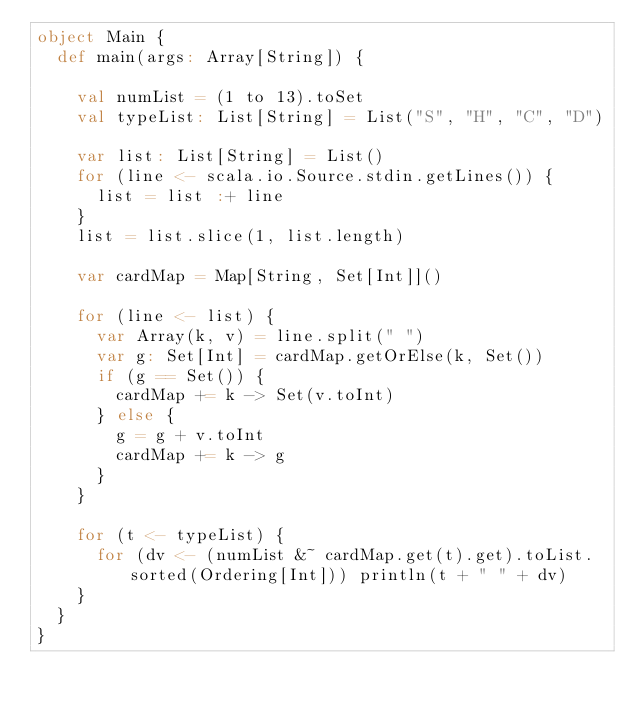<code> <loc_0><loc_0><loc_500><loc_500><_Scala_>object Main {
  def main(args: Array[String]) {

    val numList = (1 to 13).toSet
    val typeList: List[String] = List("S", "H", "C", "D")

    var list: List[String] = List()
    for (line <- scala.io.Source.stdin.getLines()) {
      list = list :+ line
    }
    list = list.slice(1, list.length)

    var cardMap = Map[String, Set[Int]]()

    for (line <- list) {
      var Array(k, v) = line.split(" ")
      var g: Set[Int] = cardMap.getOrElse(k, Set())
      if (g == Set()) {
        cardMap += k -> Set(v.toInt)
      } else {
        g = g + v.toInt
        cardMap += k -> g
      }
    }

    for (t <- typeList) {
      for (dv <- (numList &~ cardMap.get(t).get).toList.sorted(Ordering[Int])) println(t + " " + dv)
    }
  }
}</code> 